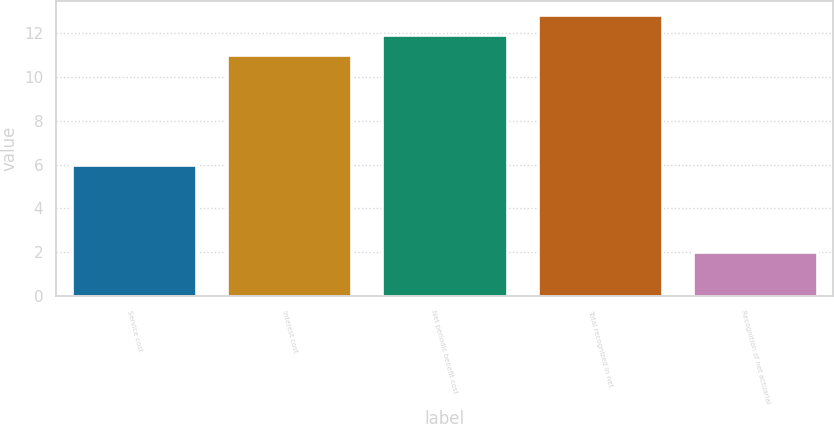<chart> <loc_0><loc_0><loc_500><loc_500><bar_chart><fcel>Service cost<fcel>Interest cost<fcel>Net periodic benefit cost<fcel>Total recognized in net<fcel>Recognition of net actuarial<nl><fcel>6<fcel>11<fcel>11.9<fcel>12.8<fcel>2<nl></chart> 